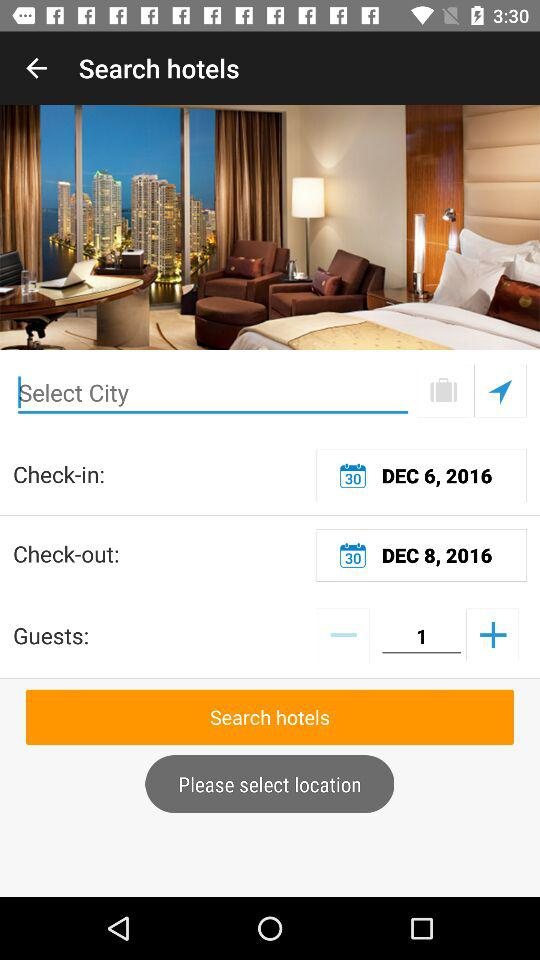How many days are between the check-in and check-out dates?
Answer the question using a single word or phrase. 2 